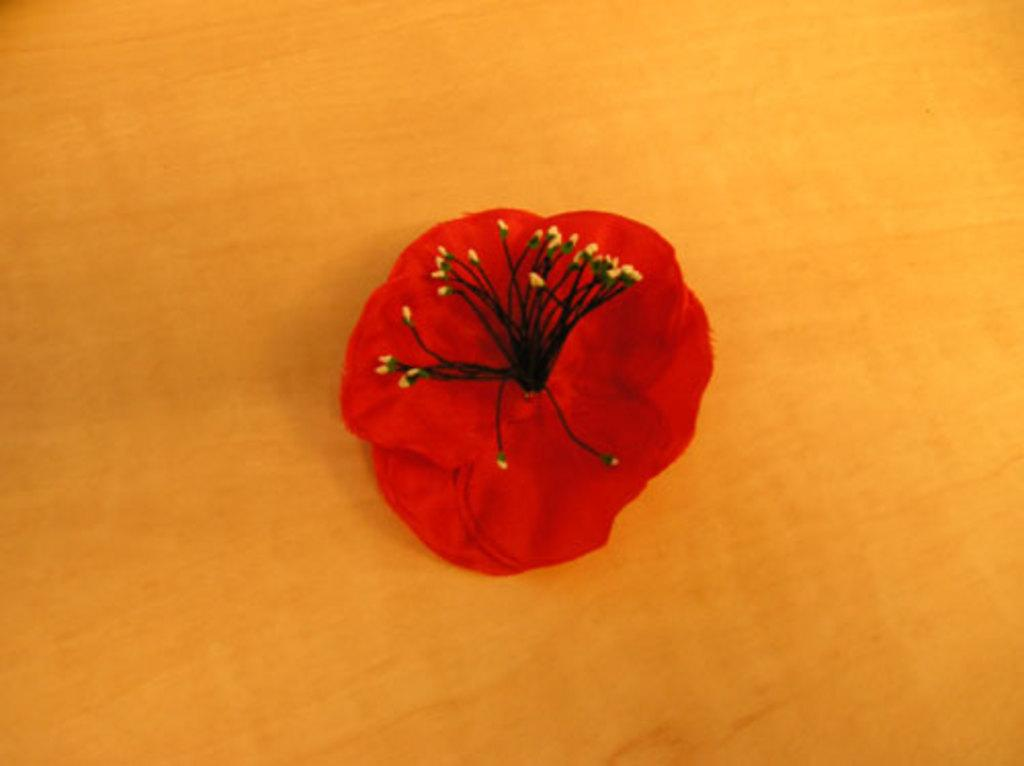What is the main subject of the image? There is a flower in the image. What can be found on the flower? The flower has pollen grains. What color is the flower? The flower appears to be red in color. Is there any information about the background of the image? The image may be on a wooden board, but this is less certain and could be a transcription error. Can you see any marks on the flower in the image? There is no mention of any marks on the flower in the provided facts, so we cannot determine if any marks are present. Is the flower in the image under attack? There is no indication of an attack or any threat to the flower in the image. 